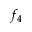Convert formula to latex. <formula><loc_0><loc_0><loc_500><loc_500>f _ { 4 }</formula> 